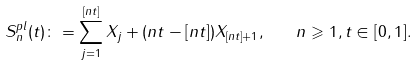Convert formula to latex. <formula><loc_0><loc_0><loc_500><loc_500>S _ { n } ^ { p l } ( t ) \colon = \sum _ { j = 1 } ^ { [ n t ] } X _ { j } + ( n t - [ n t ] ) X _ { [ n t ] + 1 } , \quad n \geqslant 1 , t \in [ 0 , 1 ] .</formula> 